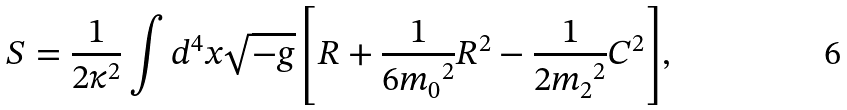Convert formula to latex. <formula><loc_0><loc_0><loc_500><loc_500>S = \frac { 1 } { 2 \kappa ^ { 2 } } \int { d ^ { 4 } x \sqrt { - g } \left [ R + \frac { 1 } { 6 { m _ { 0 } } ^ { 2 } } R ^ { 2 } - \frac { 1 } { 2 { m _ { 2 } } ^ { 2 } } C ^ { 2 } \right ] } ,</formula> 